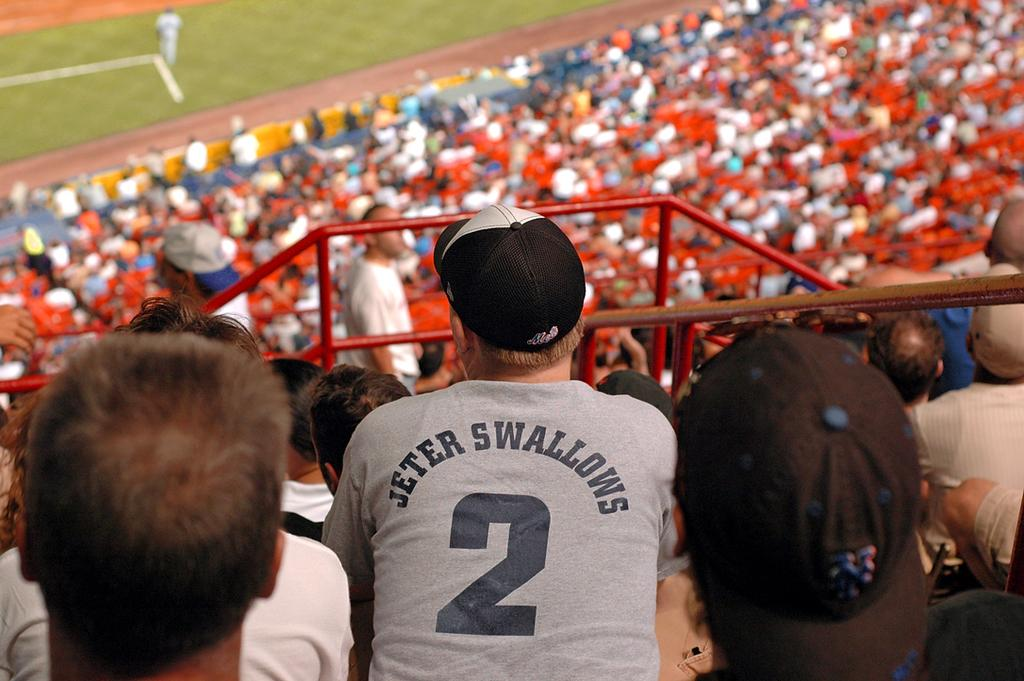What is the main setting of the image? The main setting of the image is a stadium. What are the people in the stadium doing? The people are sitting at the stadium and watching a person standing on the ground. Can you describe the person standing on the ground? There is no specific description of the person standing on the ground, but they are the focus of attention for the people in the stadium. What type of mist can be seen surrounding the person standing on the ground? There is no mist present in the image; it is a clear scene with people sitting in a stadium and watching a person standing on the ground. 